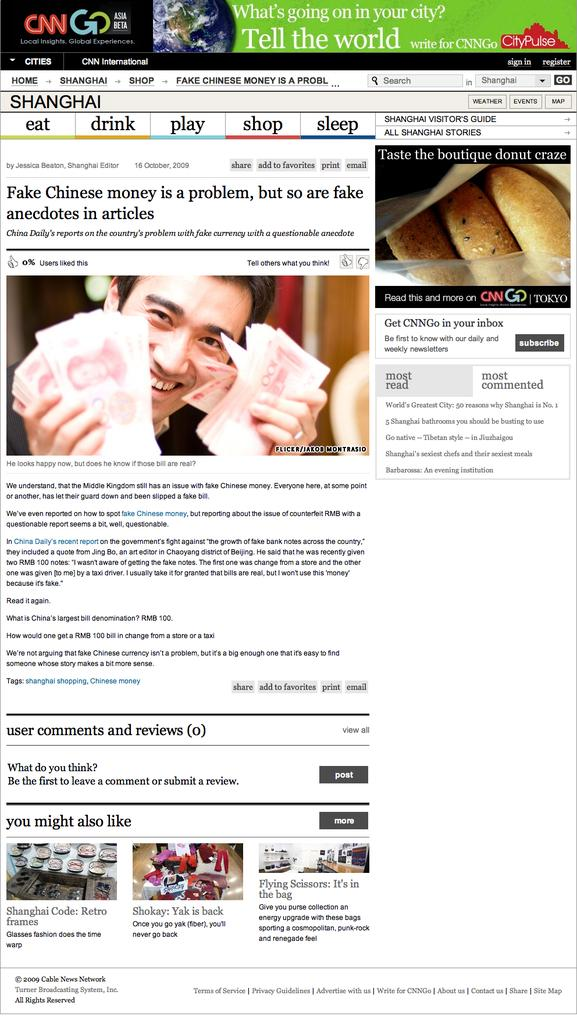What is the main subject in the center of the image? There is a poster in the center of the image. What type of quilt is being used for driving in the image? There is no quilt or driving activity present in the image; it only features a poster. 